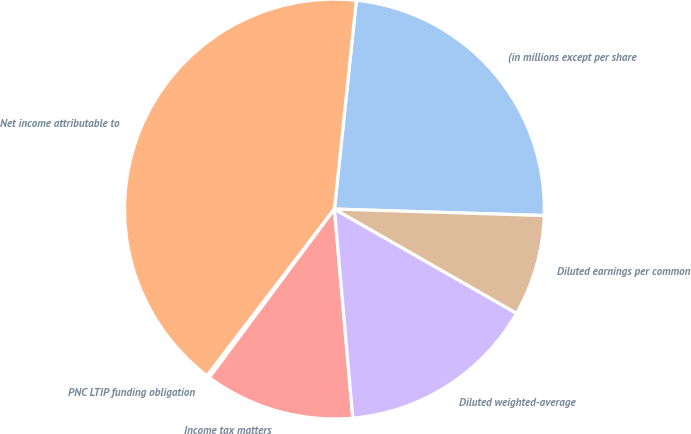<chart> <loc_0><loc_0><loc_500><loc_500><pie_chart><fcel>(in millions except per share<fcel>Net income attributable to<fcel>PNC LTIP funding obligation<fcel>Income tax matters<fcel>Diluted weighted-average<fcel>Diluted earnings per common<nl><fcel>23.83%<fcel>41.28%<fcel>0.22%<fcel>11.56%<fcel>15.33%<fcel>7.78%<nl></chart> 